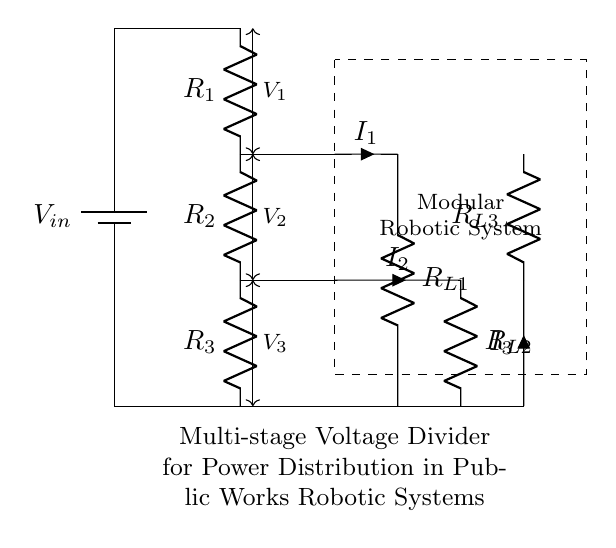What is the input voltage to the circuit? The input voltage is labeled as V_in at the top of the circuit diagram, which indicates the source voltage provided to the voltage divider.
Answer: V_in What type of components are used in this circuit? The circuit consists of resistors, which are denoted by 'R' and are marked as R_1, R_2, R_3, and load resistors R_L1, R_L2, R_L3. Additionally, there is a battery component indicating the voltage source.
Answer: Resistors and a battery What are the voltages across each resistor? The circuit shows three voltage drops across each resistor: V_1 across R_1, V_2 across R_2, and V_3 across R_3, respectively. These voltages can be measured as the potential difference between the points connected by each resistor.
Answer: V_1, V_2, V_3 How many stages are there in this multi-stage voltage divider? The circuit comprises three resistors in series, which constitutes three stages of voltage division in the circuit. Each resistor reduces the voltage further, representing a stage in the divider.
Answer: Three What is the purpose of the load resistors in the diagram? The load resistors R_L1, R_L2, and R_L3 are placed below the main resistors and provide a path for current to flow, simulating real conditions where power is distributed to different modules in a robotic system. They allow for analyzing how the voltage divides among multiple loads connected to the circuit.
Answer: Power distribution What happens to the total current in the circuit as it passes through the resistors? As the current flows through each resistor in series, it experiences a reduction in current due to the voltage drop across each resistor. The same current (I) flows through R_1, R_2, and R_3, but the voltage across each will be different. Therefore, I_1 equals I_2 equals I_3, demonstrating that current remains the same in a series configuration.
Answer: It remains constant What is the implication of using a multi-stage voltage divider in public works robotic systems? A multi-stage voltage divider allows for precise control and distribution of power to various components of modular robotic systems, ensuring each module receives the appropriate voltage for its operation. This is critical for efficiency and reliability in public works projects.
Answer: Precise voltage control 